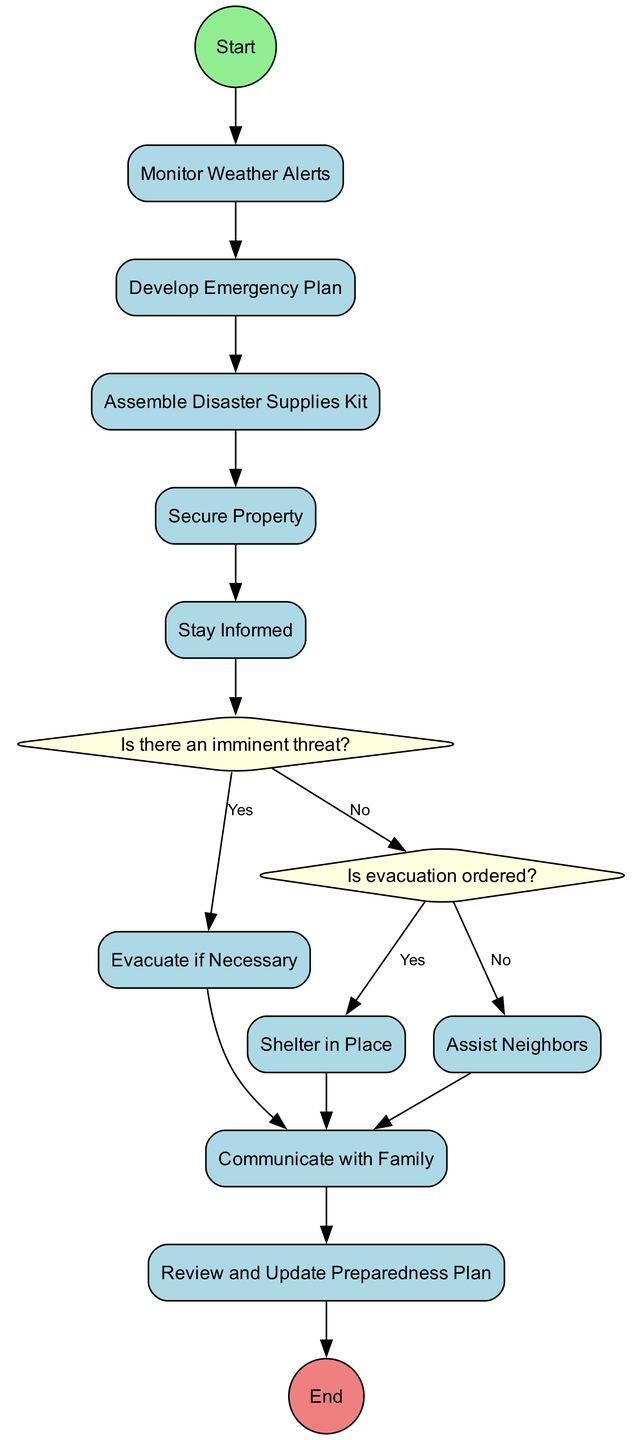What is the first activity in the diagram? The diagram starts with the 'Start' node, which connects to the first activity, 'Monitor Weather Alerts'. This is the first action residents must take in emergency preparedness.
Answer: Monitor Weather Alerts How many activities are listed in the diagram? There are ten activities outlined in the diagram, including 'Monitor Weather Alerts' and 'Review and Update Preparedness Plan'. Counting each activity node gives a total of ten.
Answer: 10 What is the relationship between 'Stay Informed' and 'Is evacuation ordered?' 'Stay Informed' is an activity that leads to the decision node 'Is evacuation ordered?'. After staying informed, the next step is to check if evacuation is necessary.
Answer: Leads to What are the possible choices in the second decision? The second decision node 'Is evacuation ordered?' has two choices: 'Yes' and 'No'. This decision is crucial for determining the subsequent action to take during a disaster.
Answer: Yes, No If the answer to 'Is there an imminent threat?' is 'No', what is the next action? If the answer is 'No', the flow continues from 'Is there an imminent threat?' to the decision 'Is evacuation ordered?'. No immediate actions follow until the next decision is made.
Answer: Is evacuation ordered? What sequence of actions occurs after assembling a disaster supplies kit? After assembling a disaster supplies kit, the action proceeds to securing the property. This preparation is crucial for ensuring safety within the home before a disaster.
Answer: Secure Property What should a family do if an evacuation is ordered? Upon evacuation orders being issued, families should quickly move to designated safe locations, following the appropriate paths determined in the emergency plan.
Answer: Evacuate if Necessary What is the final step in the emergency preparedness process? The final step in the diagram after going through the various activities and decisions is 'End'. This signifies the completion of the emergency preparedness planning process.
Answer: End How does 'Assist Neighbors' relate to the overall emergency preparedness plan? 'Assist Neighbors' is positioned after evacuation decisions, highlighting community support as part of the preparedness process. Ensuring neighbors are taken care of is essential in preparedness efforts.
Answer: Community support 